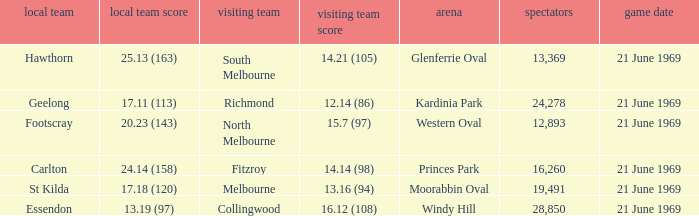When did an away team score 15.7 (97)? 21 June 1969. 